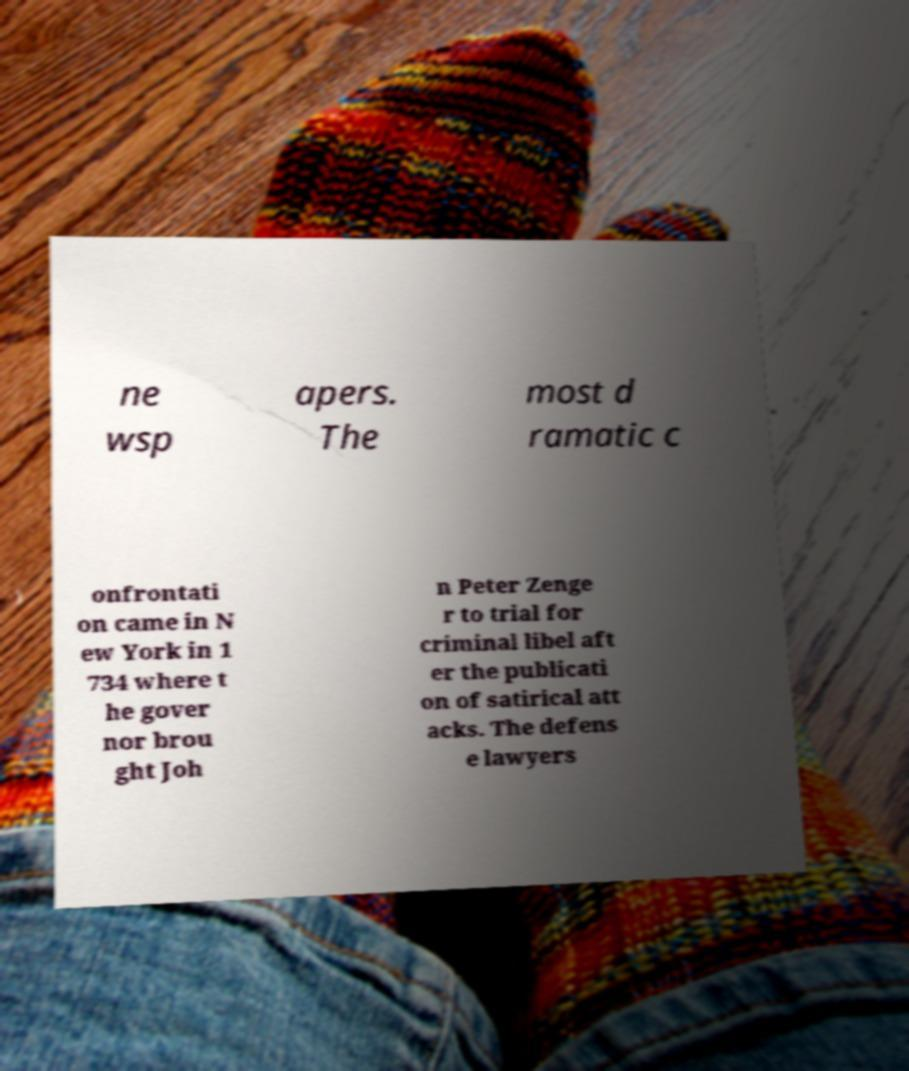Could you assist in decoding the text presented in this image and type it out clearly? ne wsp apers. The most d ramatic c onfrontati on came in N ew York in 1 734 where t he gover nor brou ght Joh n Peter Zenge r to trial for criminal libel aft er the publicati on of satirical att acks. The defens e lawyers 